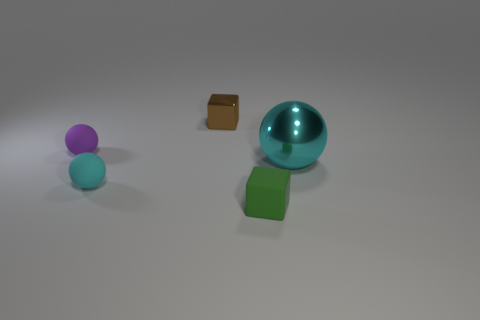Subtract all small rubber spheres. How many spheres are left? 1 Subtract all yellow cylinders. How many cyan spheres are left? 2 Add 1 shiny things. How many objects exist? 6 Subtract all brown spheres. Subtract all cyan blocks. How many spheres are left? 3 Subtract all cubes. How many objects are left? 3 Subtract 0 cyan cubes. How many objects are left? 5 Subtract all tiny green matte cubes. Subtract all purple cubes. How many objects are left? 4 Add 2 purple matte spheres. How many purple matte spheres are left? 3 Add 2 small matte blocks. How many small matte blocks exist? 3 